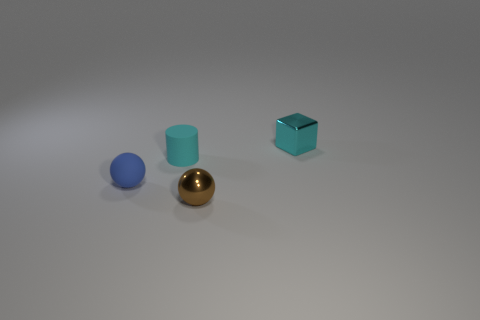What shape is the rubber object that is behind the tiny blue rubber thing behind the shiny object left of the cyan metal cube? The rubber object positioned behind the small blue sphere and to the left of the cyan metal cube is cylindrical in shape. Its smooth surface and curved edges are indicative of its cylindrical form. 